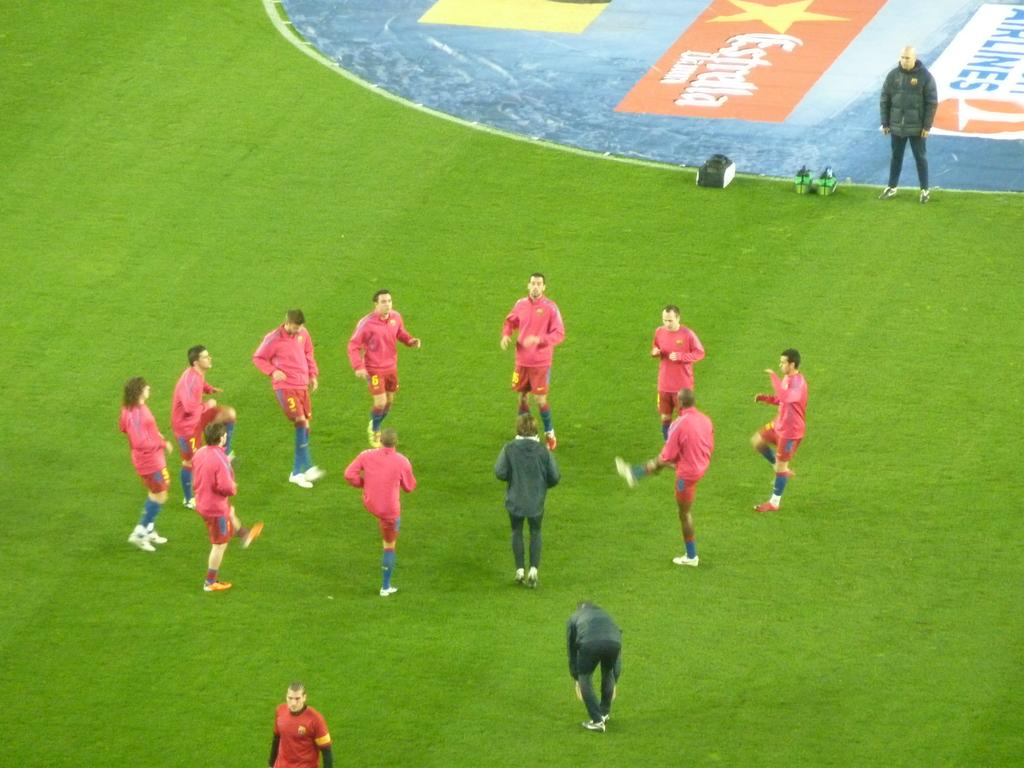<image>
Write a terse but informative summary of the picture. Soccer players on a field with an advertisement for airlines nearby. 